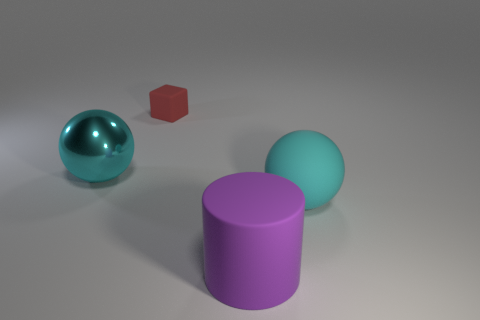Add 3 blue rubber cubes. How many objects exist? 7 Subtract all cylinders. How many objects are left? 3 Subtract all rubber balls. Subtract all rubber balls. How many objects are left? 2 Add 4 tiny red objects. How many tiny red objects are left? 5 Add 2 cyan matte objects. How many cyan matte objects exist? 3 Subtract 0 cyan cylinders. How many objects are left? 4 